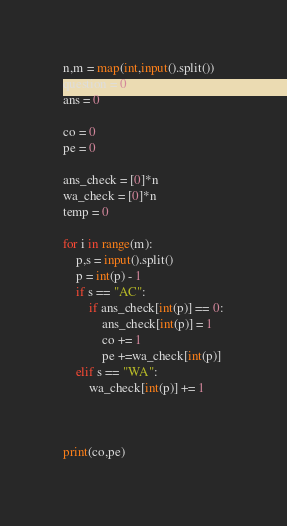Convert code to text. <code><loc_0><loc_0><loc_500><loc_500><_Python_>n,m = map(int,input().split())
question = 0
ans = 0

co = 0
pe = 0

ans_check = [0]*n
wa_check = [0]*n
temp = 0

for i in range(m):
    p,s = input().split()
    p = int(p) - 1
    if s == "AC":
        if ans_check[int(p)] == 0:
            ans_check[int(p)] = 1
            co += 1
            pe +=wa_check[int(p)]
    elif s == "WA":
        wa_check[int(p)] += 1
    


print(co,pe)

</code> 